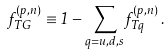<formula> <loc_0><loc_0><loc_500><loc_500>f ^ { ( p , n ) } _ { T G } \equiv 1 - \sum _ { q = u , d , s } f ^ { ( p , n ) } _ { T q } \, .</formula> 